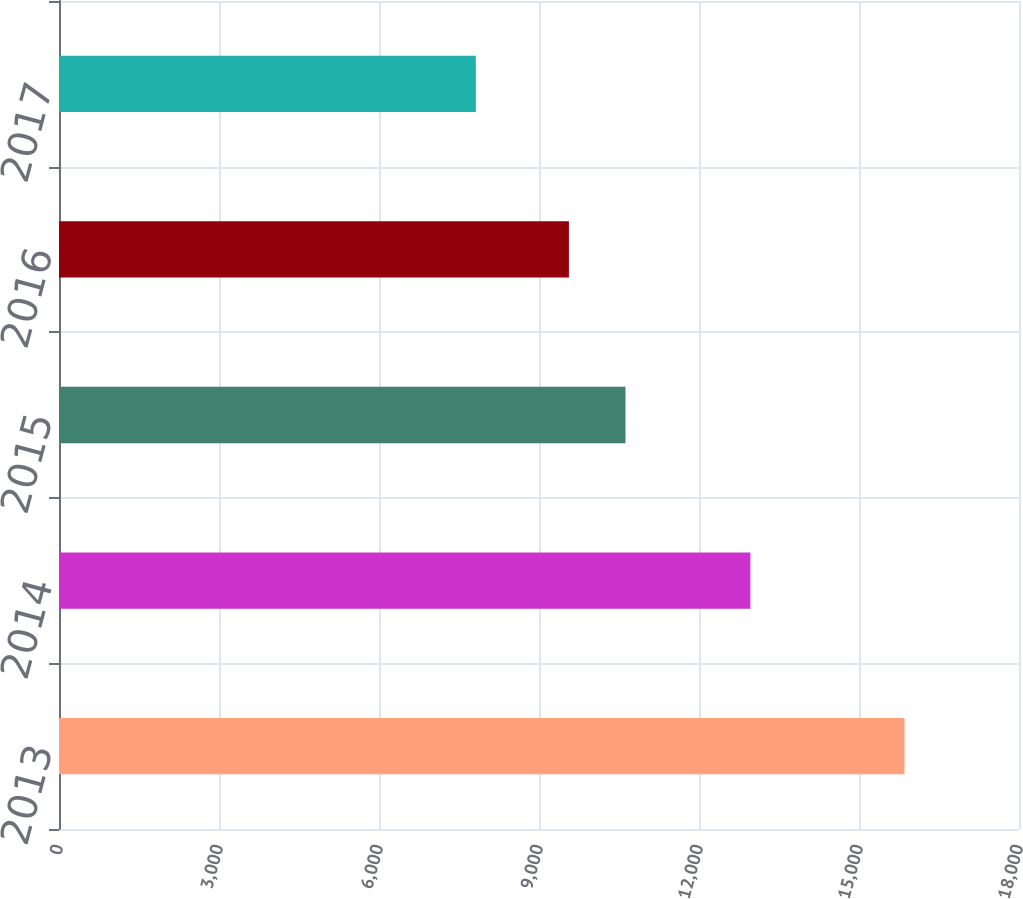Convert chart to OTSL. <chart><loc_0><loc_0><loc_500><loc_500><bar_chart><fcel>2013<fcel>2014<fcel>2015<fcel>2016<fcel>2017<nl><fcel>15853<fcel>12964<fcel>10622<fcel>9561<fcel>7816<nl></chart> 